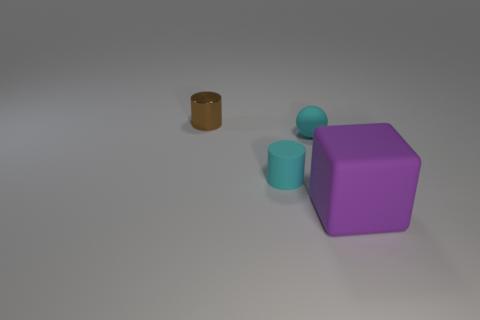Add 4 big blue metallic things. How many objects exist? 8 Subtract 0 yellow balls. How many objects are left? 4 Subtract all balls. How many objects are left? 3 Subtract all cyan objects. Subtract all blocks. How many objects are left? 1 Add 4 small spheres. How many small spheres are left? 5 Add 2 big cubes. How many big cubes exist? 3 